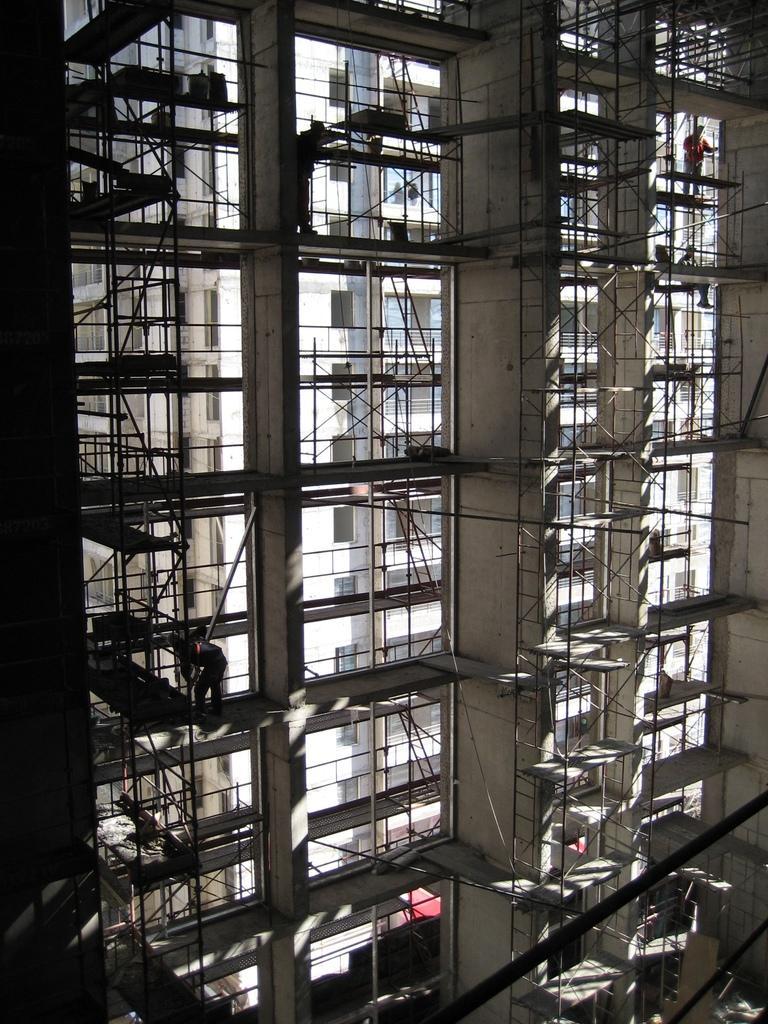Can you describe this image briefly? In this image, I can see the buildings, which are construction in progress. I can see a person standing and working. I think these are the ladders. Here is another person standing. I can see the pillars of the building. 